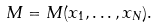<formula> <loc_0><loc_0><loc_500><loc_500>M = M ( x _ { 1 } , \dots , x _ { N } ) .</formula> 